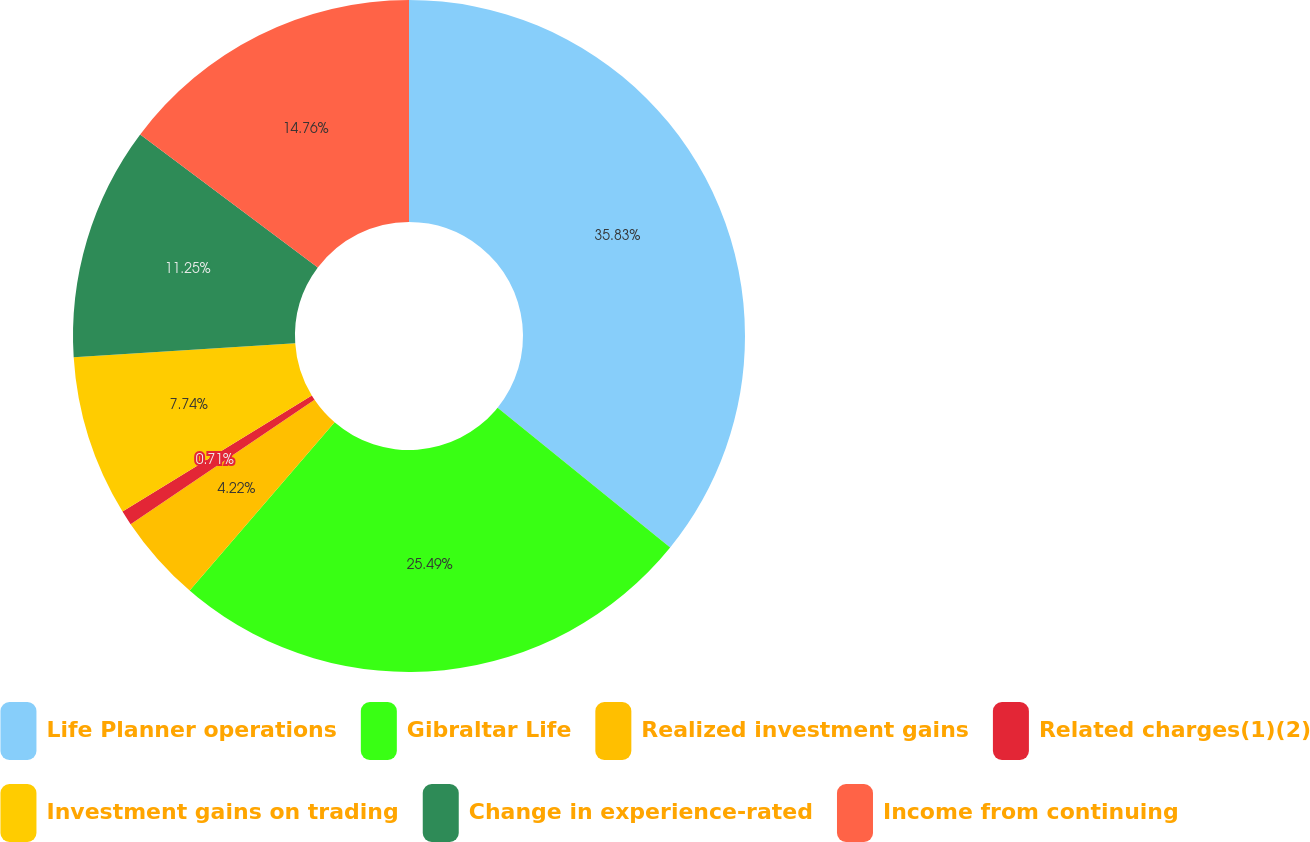Convert chart to OTSL. <chart><loc_0><loc_0><loc_500><loc_500><pie_chart><fcel>Life Planner operations<fcel>Gibraltar Life<fcel>Realized investment gains<fcel>Related charges(1)(2)<fcel>Investment gains on trading<fcel>Change in experience-rated<fcel>Income from continuing<nl><fcel>35.83%<fcel>25.49%<fcel>4.22%<fcel>0.71%<fcel>7.74%<fcel>11.25%<fcel>14.76%<nl></chart> 